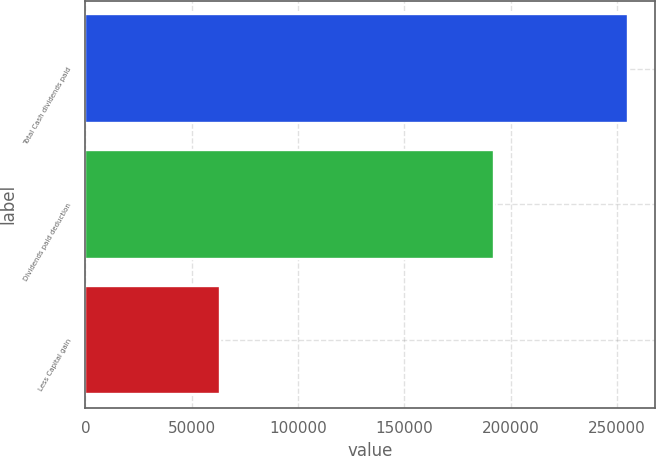<chart> <loc_0><loc_0><loc_500><loc_500><bar_chart><fcel>Total Cash dividends paid<fcel>Dividends paid deduction<fcel>Less Capital gain<nl><fcel>255279<fcel>192083<fcel>63196<nl></chart> 